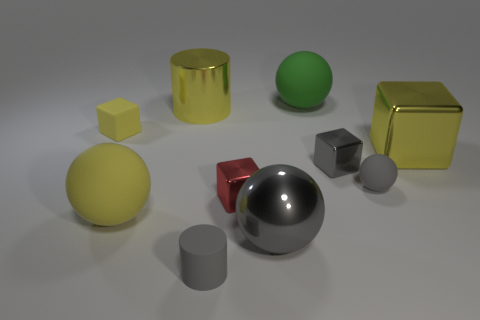Subtract all yellow rubber cubes. How many cubes are left? 3 Subtract 3 balls. How many balls are left? 1 Subtract all cylinders. How many objects are left? 8 Subtract all blue cubes. How many purple cylinders are left? 0 Subtract all big gray rubber spheres. Subtract all cubes. How many objects are left? 6 Add 8 large yellow shiny cylinders. How many large yellow shiny cylinders are left? 9 Add 7 tiny red rubber cylinders. How many tiny red rubber cylinders exist? 7 Subtract all yellow cylinders. How many cylinders are left? 1 Subtract 1 gray cubes. How many objects are left? 9 Subtract all blue blocks. Subtract all green cylinders. How many blocks are left? 4 